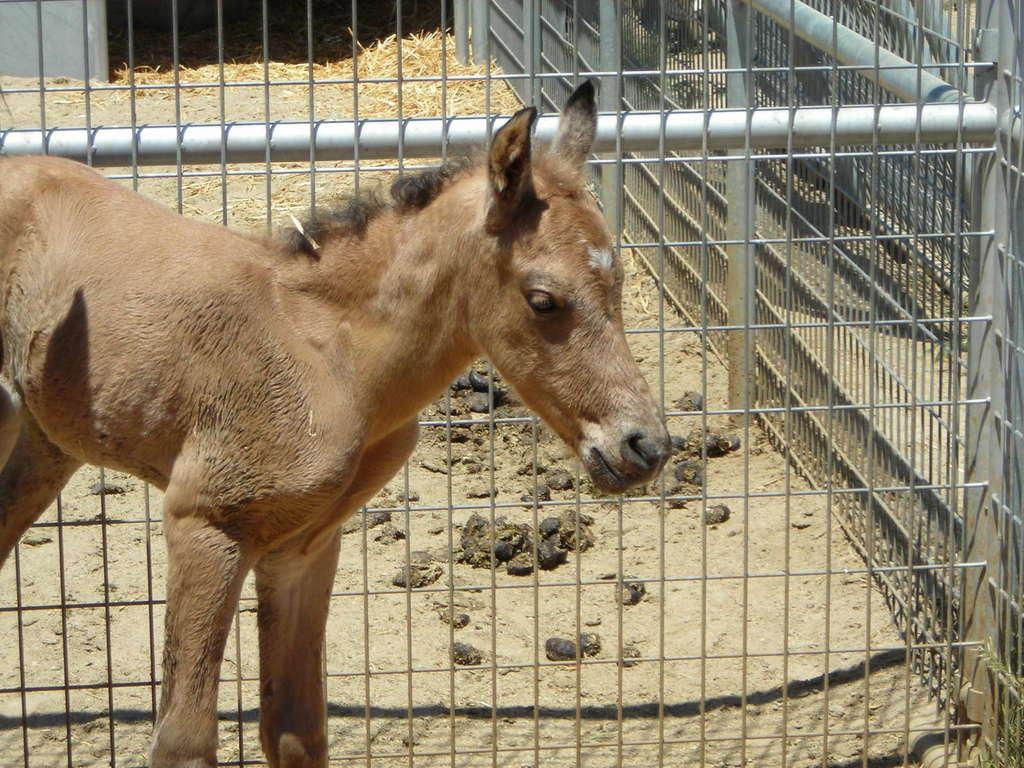Describe this image in one or two sentences. There is a donkey at the bottom of this image. We can see a mesh and some grass in the background. 